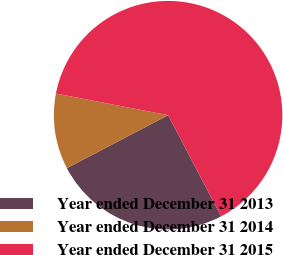<chart> <loc_0><loc_0><loc_500><loc_500><pie_chart><fcel>Year ended December 31 2013<fcel>Year ended December 31 2014<fcel>Year ended December 31 2015<nl><fcel>25.0%<fcel>10.71%<fcel>64.29%<nl></chart> 